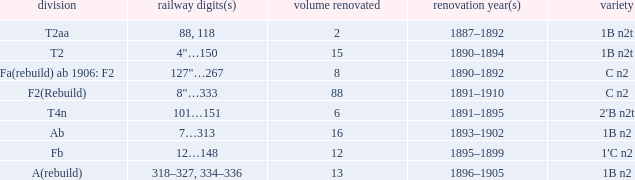Write the full table. {'header': ['division', 'railway digits(s)', 'volume renovated', 'renovation year(s)', 'variety'], 'rows': [['T2aa', '88, 118', '2', '1887–1892', '1B n2t'], ['T2', '4"…150', '15', '1890–1894', '1B n2t'], ['Fa(rebuild) ab 1906: F2', '127"…267', '8', '1890–1892', 'C n2'], ['F2(Rebuild)', '8"…333', '88', '1891–1910', 'C n2'], ['T4n', '101…151', '6', '1891–1895', '2′B n2t'], ['Ab', '7…313', '16', '1893–1902', '1B n2'], ['Fb', '12…148', '12', '1895–1899', '1′C n2'], ['A(rebuild)', '318–327, 334–336', '13', '1896–1905', '1B n2']]} What is the total of quantity rebuilt if the type is 1B N2T and the railway number is 88, 118? 1.0. 